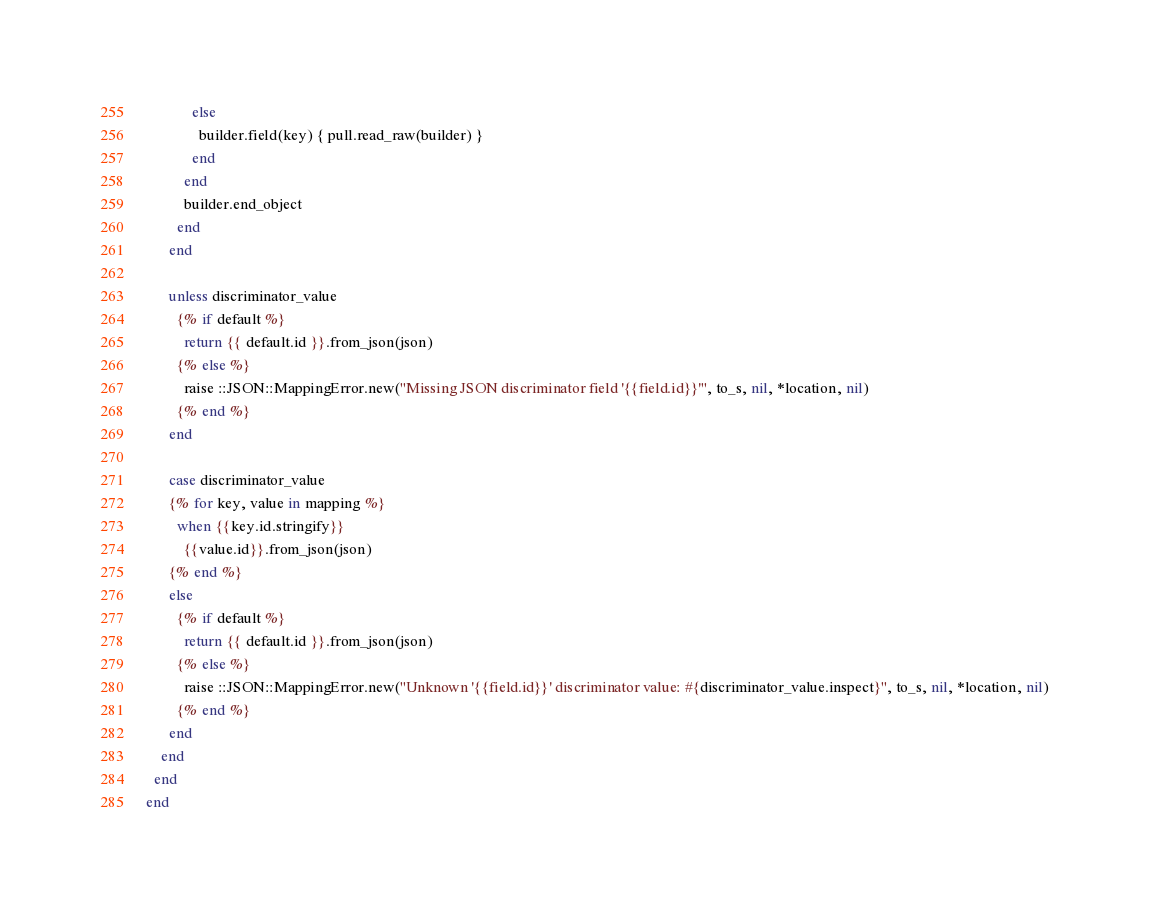Convert code to text. <code><loc_0><loc_0><loc_500><loc_500><_Crystal_>            else
              builder.field(key) { pull.read_raw(builder) }
            end
          end
          builder.end_object
        end
      end

      unless discriminator_value
        {% if default %}
          return {{ default.id }}.from_json(json)
        {% else %}
          raise ::JSON::MappingError.new("Missing JSON discriminator field '{{field.id}}'", to_s, nil, *location, nil)
        {% end %}
      end

      case discriminator_value
      {% for key, value in mapping %}
        when {{key.id.stringify}}
          {{value.id}}.from_json(json)
      {% end %}
      else
        {% if default %}
          return {{ default.id }}.from_json(json)
        {% else %}
          raise ::JSON::MappingError.new("Unknown '{{field.id}}' discriminator value: #{discriminator_value.inspect}", to_s, nil, *location, nil)
        {% end %}
      end
    end
  end
end
</code> 